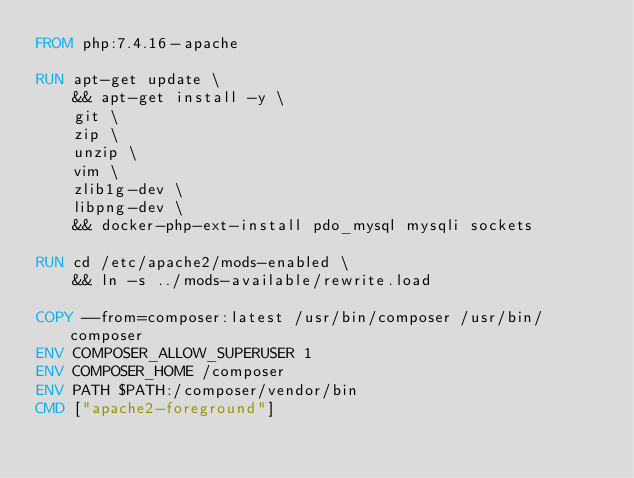Convert code to text. <code><loc_0><loc_0><loc_500><loc_500><_Dockerfile_>FROM php:7.4.16-apache

RUN apt-get update \
    && apt-get install -y \
    git \
    zip \
    unzip \
    vim \
    zlib1g-dev \
    libpng-dev \
    && docker-php-ext-install pdo_mysql mysqli sockets

RUN cd /etc/apache2/mods-enabled \
    && ln -s ../mods-available/rewrite.load

COPY --from=composer:latest /usr/bin/composer /usr/bin/composer
ENV COMPOSER_ALLOW_SUPERUSER 1
ENV COMPOSER_HOME /composer
ENV PATH $PATH:/composer/vendor/bin
CMD ["apache2-foreground"]</code> 